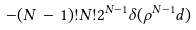<formula> <loc_0><loc_0><loc_500><loc_500>- ( N \, - \, 1 ) ! N ! 2 ^ { N - 1 } \delta ( \rho ^ { N - 1 } d )</formula> 